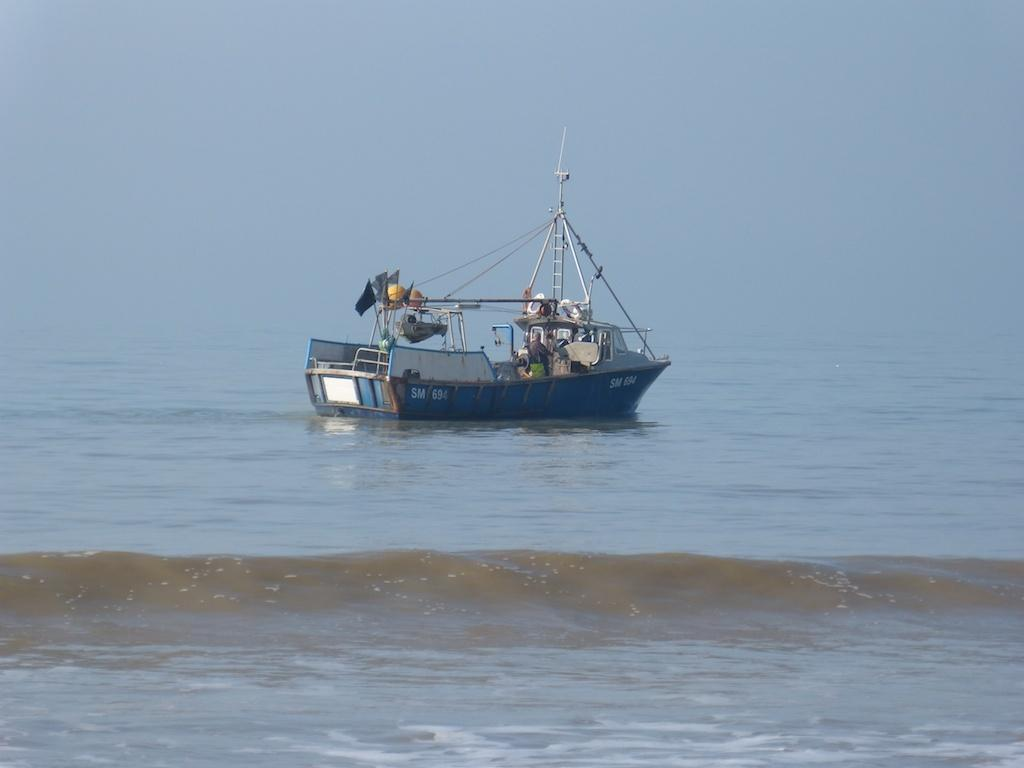What is the main subject of the image? The main subject of the image is a ship above the water. What other objects can be seen in the image? Poles and ropes are visible in the image. What can be seen in the background of the image? The sky is visible in the background of the image. What time of day is it in the image, given the presence of a bee? There is no bee present in the image, so we cannot determine the time of day based on that information. 